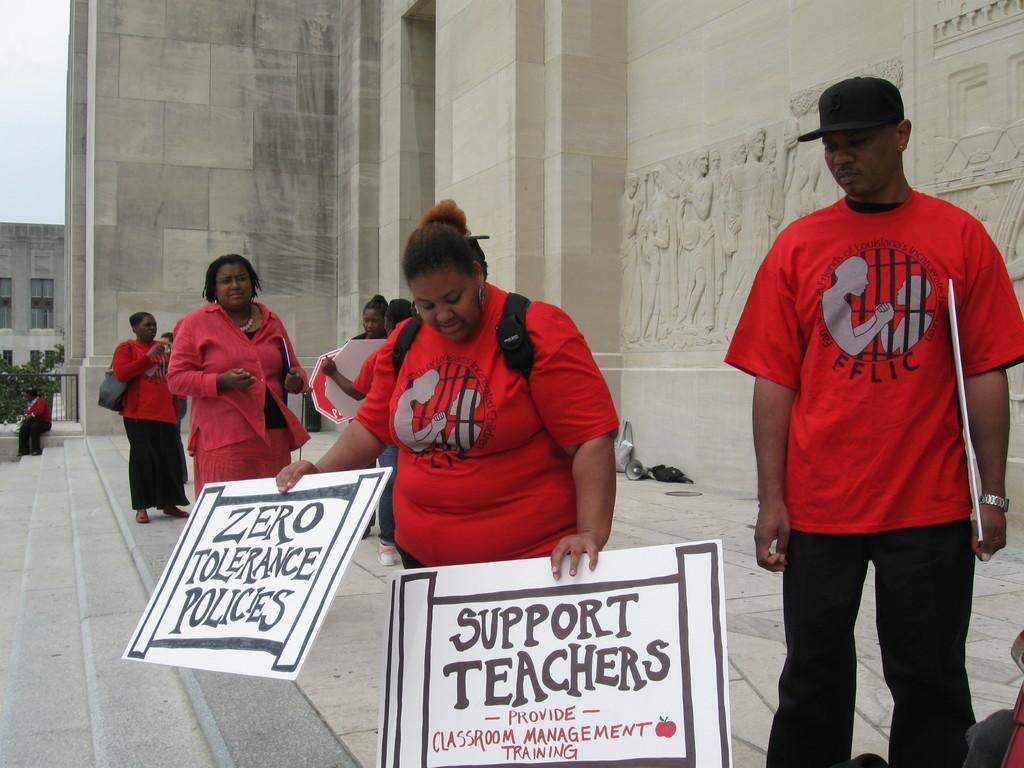How would you summarize this image in a sentence or two? A woman is holding boards, where people are standing, this is a building and a sky. 